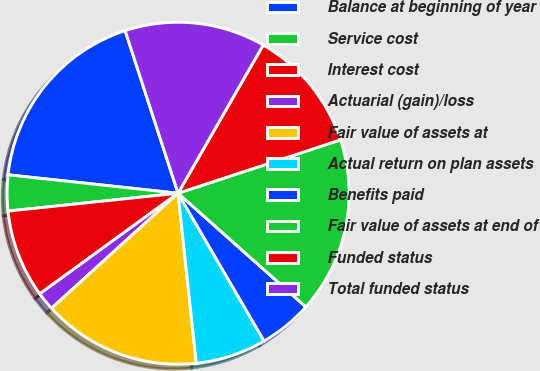Convert chart to OTSL. <chart><loc_0><loc_0><loc_500><loc_500><pie_chart><fcel>Balance at beginning of year<fcel>Service cost<fcel>Interest cost<fcel>Actuarial (gain)/loss<fcel>Fair value of assets at<fcel>Actual return on plan assets<fcel>Benefits paid<fcel>Fair value of assets at end of<fcel>Funded status<fcel>Total funded status<nl><fcel>18.27%<fcel>3.38%<fcel>8.35%<fcel>1.73%<fcel>14.96%<fcel>6.69%<fcel>5.04%<fcel>16.62%<fcel>11.65%<fcel>13.31%<nl></chart> 